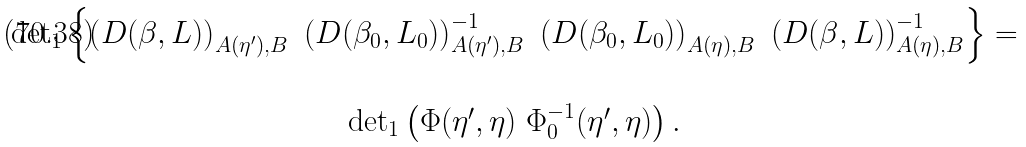<formula> <loc_0><loc_0><loc_500><loc_500>\begin{array} { c } \det \nolimits _ { 1 } \left \{ \left ( D ( \beta , L ) \right ) _ { A ( \eta ^ { \prime } ) , B } \ \left ( D ( \beta _ { 0 } , L _ { 0 } ) \right ) _ { A ( \eta ^ { \prime } ) , B } ^ { - 1 } \ \left ( D ( \beta _ { 0 } , L _ { 0 } ) \right ) _ { A ( \eta ) , B } \ \left ( D ( \beta , L ) \right ) _ { A ( \eta ) , B } ^ { - 1 } \right \} = \\ \\ \det \nolimits _ { 1 } \left ( \Phi ( \eta ^ { \prime } , \eta ) \ \Phi _ { 0 } ^ { - 1 } ( \eta ^ { \prime } , \eta ) \right ) . \end{array}</formula> 